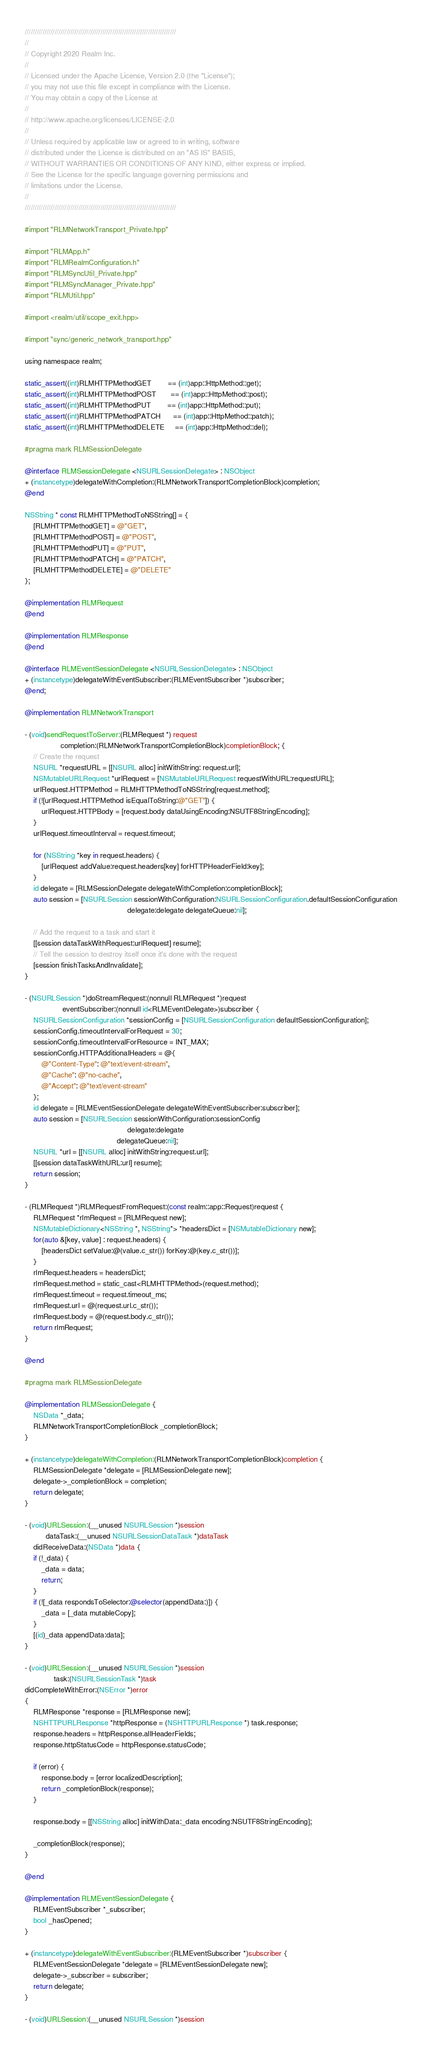<code> <loc_0><loc_0><loc_500><loc_500><_ObjectiveC_>////////////////////////////////////////////////////////////////////////////
//
// Copyright 2020 Realm Inc.
//
// Licensed under the Apache License, Version 2.0 (the "License");
// you may not use this file except in compliance with the License.
// You may obtain a copy of the License at
//
// http://www.apache.org/licenses/LICENSE-2.0
//
// Unless required by applicable law or agreed to in writing, software
// distributed under the License is distributed on an "AS IS" BASIS,
// WITHOUT WARRANTIES OR CONDITIONS OF ANY KIND, either express or implied.
// See the License for the specific language governing permissions and
// limitations under the License.
//
////////////////////////////////////////////////////////////////////////////

#import "RLMNetworkTransport_Private.hpp"

#import "RLMApp.h"
#import "RLMRealmConfiguration.h"
#import "RLMSyncUtil_Private.hpp"
#import "RLMSyncManager_Private.hpp"
#import "RLMUtil.hpp"

#import <realm/util/scope_exit.hpp>

#import "sync/generic_network_transport.hpp"

using namespace realm;

static_assert((int)RLMHTTPMethodGET        == (int)app::HttpMethod::get);
static_assert((int)RLMHTTPMethodPOST       == (int)app::HttpMethod::post);
static_assert((int)RLMHTTPMethodPUT        == (int)app::HttpMethod::put);
static_assert((int)RLMHTTPMethodPATCH      == (int)app::HttpMethod::patch);
static_assert((int)RLMHTTPMethodDELETE     == (int)app::HttpMethod::del);

#pragma mark RLMSessionDelegate

@interface RLMSessionDelegate <NSURLSessionDelegate> : NSObject
+ (instancetype)delegateWithCompletion:(RLMNetworkTransportCompletionBlock)completion;
@end

NSString * const RLMHTTPMethodToNSString[] = {
    [RLMHTTPMethodGET] = @"GET",
    [RLMHTTPMethodPOST] = @"POST",
    [RLMHTTPMethodPUT] = @"PUT",
    [RLMHTTPMethodPATCH] = @"PATCH",
    [RLMHTTPMethodDELETE] = @"DELETE"
};

@implementation RLMRequest
@end

@implementation RLMResponse
@end

@interface RLMEventSessionDelegate <NSURLSessionDelegate> : NSObject
+ (instancetype)delegateWithEventSubscriber:(RLMEventSubscriber *)subscriber;
@end;

@implementation RLMNetworkTransport

- (void)sendRequestToServer:(RLMRequest *) request
                 completion:(RLMNetworkTransportCompletionBlock)completionBlock; {
    // Create the request
    NSURL *requestURL = [[NSURL alloc] initWithString: request.url];
    NSMutableURLRequest *urlRequest = [NSMutableURLRequest requestWithURL:requestURL];
    urlRequest.HTTPMethod = RLMHTTPMethodToNSString[request.method];
    if (![urlRequest.HTTPMethod isEqualToString:@"GET"]) {
        urlRequest.HTTPBody = [request.body dataUsingEncoding:NSUTF8StringEncoding];
    }
    urlRequest.timeoutInterval = request.timeout;

    for (NSString *key in request.headers) {
        [urlRequest addValue:request.headers[key] forHTTPHeaderField:key];
    }
    id delegate = [RLMSessionDelegate delegateWithCompletion:completionBlock];
    auto session = [NSURLSession sessionWithConfiguration:NSURLSessionConfiguration.defaultSessionConfiguration
                                                 delegate:delegate delegateQueue:nil];

    // Add the request to a task and start it
    [[session dataTaskWithRequest:urlRequest] resume];
    // Tell the session to destroy itself once it's done with the request
    [session finishTasksAndInvalidate];
}

- (NSURLSession *)doStreamRequest:(nonnull RLMRequest *)request
                  eventSubscriber:(nonnull id<RLMEventDelegate>)subscriber {
    NSURLSessionConfiguration *sessionConfig = [NSURLSessionConfiguration defaultSessionConfiguration];
    sessionConfig.timeoutIntervalForRequest = 30;
    sessionConfig.timeoutIntervalForResource = INT_MAX;
    sessionConfig.HTTPAdditionalHeaders = @{
        @"Content-Type": @"text/event-stream",
        @"Cache": @"no-cache",
        @"Accept": @"text/event-stream"
    };
    id delegate = [RLMEventSessionDelegate delegateWithEventSubscriber:subscriber];
    auto session = [NSURLSession sessionWithConfiguration:sessionConfig
                                                 delegate:delegate
                                            delegateQueue:nil];
    NSURL *url = [[NSURL alloc] initWithString:request.url];
    [[session dataTaskWithURL:url] resume];
    return session;
}

- (RLMRequest *)RLMRequestFromRequest:(const realm::app::Request)request {
    RLMRequest *rlmRequest = [RLMRequest new];
    NSMutableDictionary<NSString *, NSString*> *headersDict = [NSMutableDictionary new];
    for(auto &[key, value] : request.headers) {
        [headersDict setValue:@(value.c_str()) forKey:@(key.c_str())];
    }
    rlmRequest.headers = headersDict;
    rlmRequest.method = static_cast<RLMHTTPMethod>(request.method);
    rlmRequest.timeout = request.timeout_ms;
    rlmRequest.url = @(request.url.c_str());
    rlmRequest.body = @(request.body.c_str());
    return rlmRequest;
}

@end

#pragma mark RLMSessionDelegate

@implementation RLMSessionDelegate {
    NSData *_data;
    RLMNetworkTransportCompletionBlock _completionBlock;
}

+ (instancetype)delegateWithCompletion:(RLMNetworkTransportCompletionBlock)completion {
    RLMSessionDelegate *delegate = [RLMSessionDelegate new];
    delegate->_completionBlock = completion;
    return delegate;
}

- (void)URLSession:(__unused NSURLSession *)session
          dataTask:(__unused NSURLSessionDataTask *)dataTask
    didReceiveData:(NSData *)data {
    if (!_data) {
        _data = data;
        return;
    }
    if (![_data respondsToSelector:@selector(appendData:)]) {
        _data = [_data mutableCopy];
    }
    [(id)_data appendData:data];
}

- (void)URLSession:(__unused NSURLSession *)session
              task:(NSURLSessionTask *)task
didCompleteWithError:(NSError *)error
{
    RLMResponse *response = [RLMResponse new];
    NSHTTPURLResponse *httpResponse = (NSHTTPURLResponse *) task.response;
    response.headers = httpResponse.allHeaderFields;
    response.httpStatusCode = httpResponse.statusCode;

    if (error) {
        response.body = [error localizedDescription];
        return _completionBlock(response);
    }

    response.body = [[NSString alloc] initWithData:_data encoding:NSUTF8StringEncoding];

    _completionBlock(response);
}

@end

@implementation RLMEventSessionDelegate {
    RLMEventSubscriber *_subscriber;
    bool _hasOpened;
}

+ (instancetype)delegateWithEventSubscriber:(RLMEventSubscriber *)subscriber {
    RLMEventSessionDelegate *delegate = [RLMEventSessionDelegate new];
    delegate->_subscriber = subscriber;
    return delegate;
}

- (void)URLSession:(__unused NSURLSession *)session</code> 